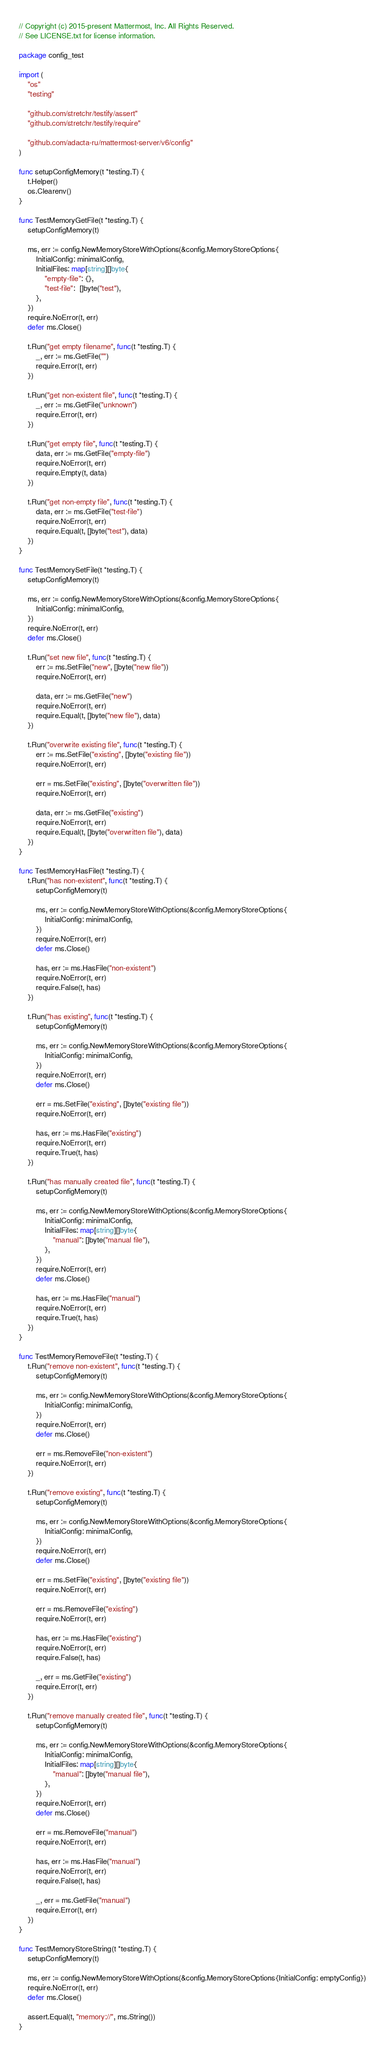Convert code to text. <code><loc_0><loc_0><loc_500><loc_500><_Go_>// Copyright (c) 2015-present Mattermost, Inc. All Rights Reserved.
// See LICENSE.txt for license information.

package config_test

import (
	"os"
	"testing"

	"github.com/stretchr/testify/assert"
	"github.com/stretchr/testify/require"

	"github.com/adacta-ru/mattermost-server/v6/config"
)

func setupConfigMemory(t *testing.T) {
	t.Helper()
	os.Clearenv()
}

func TestMemoryGetFile(t *testing.T) {
	setupConfigMemory(t)

	ms, err := config.NewMemoryStoreWithOptions(&config.MemoryStoreOptions{
		InitialConfig: minimalConfig,
		InitialFiles: map[string][]byte{
			"empty-file": {},
			"test-file":  []byte("test"),
		},
	})
	require.NoError(t, err)
	defer ms.Close()

	t.Run("get empty filename", func(t *testing.T) {
		_, err := ms.GetFile("")
		require.Error(t, err)
	})

	t.Run("get non-existent file", func(t *testing.T) {
		_, err := ms.GetFile("unknown")
		require.Error(t, err)
	})

	t.Run("get empty file", func(t *testing.T) {
		data, err := ms.GetFile("empty-file")
		require.NoError(t, err)
		require.Empty(t, data)
	})

	t.Run("get non-empty file", func(t *testing.T) {
		data, err := ms.GetFile("test-file")
		require.NoError(t, err)
		require.Equal(t, []byte("test"), data)
	})
}

func TestMemorySetFile(t *testing.T) {
	setupConfigMemory(t)

	ms, err := config.NewMemoryStoreWithOptions(&config.MemoryStoreOptions{
		InitialConfig: minimalConfig,
	})
	require.NoError(t, err)
	defer ms.Close()

	t.Run("set new file", func(t *testing.T) {
		err := ms.SetFile("new", []byte("new file"))
		require.NoError(t, err)

		data, err := ms.GetFile("new")
		require.NoError(t, err)
		require.Equal(t, []byte("new file"), data)
	})

	t.Run("overwrite existing file", func(t *testing.T) {
		err := ms.SetFile("existing", []byte("existing file"))
		require.NoError(t, err)

		err = ms.SetFile("existing", []byte("overwritten file"))
		require.NoError(t, err)

		data, err := ms.GetFile("existing")
		require.NoError(t, err)
		require.Equal(t, []byte("overwritten file"), data)
	})
}

func TestMemoryHasFile(t *testing.T) {
	t.Run("has non-existent", func(t *testing.T) {
		setupConfigMemory(t)

		ms, err := config.NewMemoryStoreWithOptions(&config.MemoryStoreOptions{
			InitialConfig: minimalConfig,
		})
		require.NoError(t, err)
		defer ms.Close()

		has, err := ms.HasFile("non-existent")
		require.NoError(t, err)
		require.False(t, has)
	})

	t.Run("has existing", func(t *testing.T) {
		setupConfigMemory(t)

		ms, err := config.NewMemoryStoreWithOptions(&config.MemoryStoreOptions{
			InitialConfig: minimalConfig,
		})
		require.NoError(t, err)
		defer ms.Close()

		err = ms.SetFile("existing", []byte("existing file"))
		require.NoError(t, err)

		has, err := ms.HasFile("existing")
		require.NoError(t, err)
		require.True(t, has)
	})

	t.Run("has manually created file", func(t *testing.T) {
		setupConfigMemory(t)

		ms, err := config.NewMemoryStoreWithOptions(&config.MemoryStoreOptions{
			InitialConfig: minimalConfig,
			InitialFiles: map[string][]byte{
				"manual": []byte("manual file"),
			},
		})
		require.NoError(t, err)
		defer ms.Close()

		has, err := ms.HasFile("manual")
		require.NoError(t, err)
		require.True(t, has)
	})
}

func TestMemoryRemoveFile(t *testing.T) {
	t.Run("remove non-existent", func(t *testing.T) {
		setupConfigMemory(t)

		ms, err := config.NewMemoryStoreWithOptions(&config.MemoryStoreOptions{
			InitialConfig: minimalConfig,
		})
		require.NoError(t, err)
		defer ms.Close()

		err = ms.RemoveFile("non-existent")
		require.NoError(t, err)
	})

	t.Run("remove existing", func(t *testing.T) {
		setupConfigMemory(t)

		ms, err := config.NewMemoryStoreWithOptions(&config.MemoryStoreOptions{
			InitialConfig: minimalConfig,
		})
		require.NoError(t, err)
		defer ms.Close()

		err = ms.SetFile("existing", []byte("existing file"))
		require.NoError(t, err)

		err = ms.RemoveFile("existing")
		require.NoError(t, err)

		has, err := ms.HasFile("existing")
		require.NoError(t, err)
		require.False(t, has)

		_, err = ms.GetFile("existing")
		require.Error(t, err)
	})

	t.Run("remove manually created file", func(t *testing.T) {
		setupConfigMemory(t)

		ms, err := config.NewMemoryStoreWithOptions(&config.MemoryStoreOptions{
			InitialConfig: minimalConfig,
			InitialFiles: map[string][]byte{
				"manual": []byte("manual file"),
			},
		})
		require.NoError(t, err)
		defer ms.Close()

		err = ms.RemoveFile("manual")
		require.NoError(t, err)

		has, err := ms.HasFile("manual")
		require.NoError(t, err)
		require.False(t, has)

		_, err = ms.GetFile("manual")
		require.Error(t, err)
	})
}

func TestMemoryStoreString(t *testing.T) {
	setupConfigMemory(t)

	ms, err := config.NewMemoryStoreWithOptions(&config.MemoryStoreOptions{InitialConfig: emptyConfig})
	require.NoError(t, err)
	defer ms.Close()

	assert.Equal(t, "memory://", ms.String())
}
</code> 